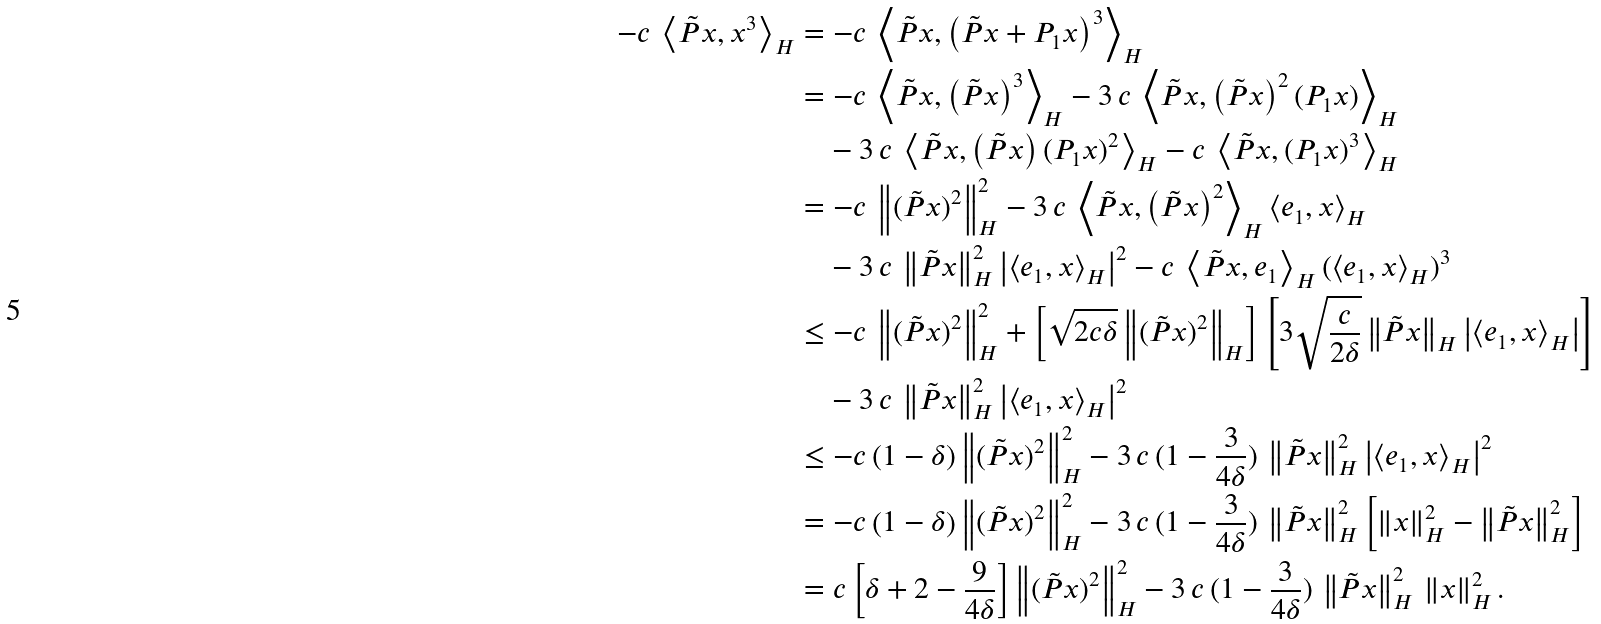<formula> <loc_0><loc_0><loc_500><loc_500>- c \, \left \langle \tilde { P } x , x ^ { 3 } \right \rangle _ { H } & = - c \, \left \langle \tilde { P } x , \left ( \tilde { P } x + P _ { 1 } x \right ) ^ { 3 } \right \rangle _ { H } \\ & = - c \, \left \langle \tilde { P } x , \left ( \tilde { P } x \right ) ^ { 3 } \right \rangle _ { H } - 3 \, c \, \left \langle \tilde { P } x , \left ( \tilde { P } x \right ) ^ { 2 } ( P _ { 1 } x ) \right \rangle _ { H } \\ & \quad - 3 \, c \, \left \langle \tilde { P } x , \left ( \tilde { P } x \right ) ( P _ { 1 } x ) ^ { 2 } \right \rangle _ { H } - c \, \left \langle \tilde { P } x , ( P _ { 1 } x ) ^ { 3 } \right \rangle _ { H } \\ & = - c \, \left \| ( \tilde { P } x ) ^ { 2 } \right \| _ { H } ^ { 2 } - 3 \, c \, \left \langle \tilde { P } x , \left ( \tilde { P } x \right ) ^ { 2 } \right \rangle _ { H } \left < e _ { 1 } , x \right > _ { H } \\ & \quad - 3 \, c \, \left \| \tilde { P } x \right \| _ { H } ^ { 2 } \left | \left < e _ { 1 } , x \right > _ { H } \right | ^ { 2 } - c \, \left \langle \tilde { P } x , e _ { 1 } \right \rangle _ { H } ( \left < e _ { 1 } , x \right > _ { H } ) ^ { 3 } \\ & \leq - c \, \left \| ( \tilde { P } x ) ^ { 2 } \right \| _ { H } ^ { 2 } + \left [ \sqrt { 2 c \delta } \left \| ( \tilde { P } x ) ^ { 2 } \right \| _ { H } \right ] \left [ 3 \sqrt { \frac { c } { 2 \delta } } \left \| \tilde { P } x \right \| _ { H } \left | \left < e _ { 1 } , x \right > _ { H } \right | \right ] \\ & \quad - 3 \, c \, \left \| \tilde { P } x \right \| _ { H } ^ { 2 } \left | \left < e _ { 1 } , x \right > _ { H } \right | ^ { 2 } \\ & \leq - c \left ( 1 - \delta \right ) \left \| ( \tilde { P } x ) ^ { 2 } \right \| _ { H } ^ { 2 } - 3 \, c \, ( 1 - \frac { 3 } { 4 \delta } ) \, \left \| \tilde { P } x \right \| _ { H } ^ { 2 } \left | \left < e _ { 1 } , x \right > _ { H } \right | ^ { 2 } \\ & = - c \left ( 1 - \delta \right ) \left \| ( \tilde { P } x ) ^ { 2 } \right \| _ { H } ^ { 2 } - 3 \, c \, ( 1 - \frac { 3 } { 4 \delta } ) \, \left \| \tilde { P } x \right \| _ { H } ^ { 2 } \left [ \| x \| ^ { 2 } _ { H } - \left \| \tilde { P } x \right \| ^ { 2 } _ { H } \right ] \\ & = c \left [ \delta + 2 - \frac { 9 } { 4 \delta } \right ] \left \| ( \tilde { P } x ) ^ { 2 } \right \| _ { H } ^ { 2 } - 3 \, c \, ( 1 - \frac { 3 } { 4 \delta } ) \, \left \| \tilde { P } x \right \| _ { H } ^ { 2 } \, \| x \| ^ { 2 } _ { H } \, .</formula> 